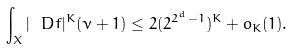<formula> <loc_0><loc_0><loc_500><loc_500>\int _ { X } | \ D f | ^ { K } ( \nu + 1 ) \leq 2 ( 2 ^ { 2 ^ { d } - 1 } ) ^ { K } + o _ { K } ( 1 ) .</formula> 